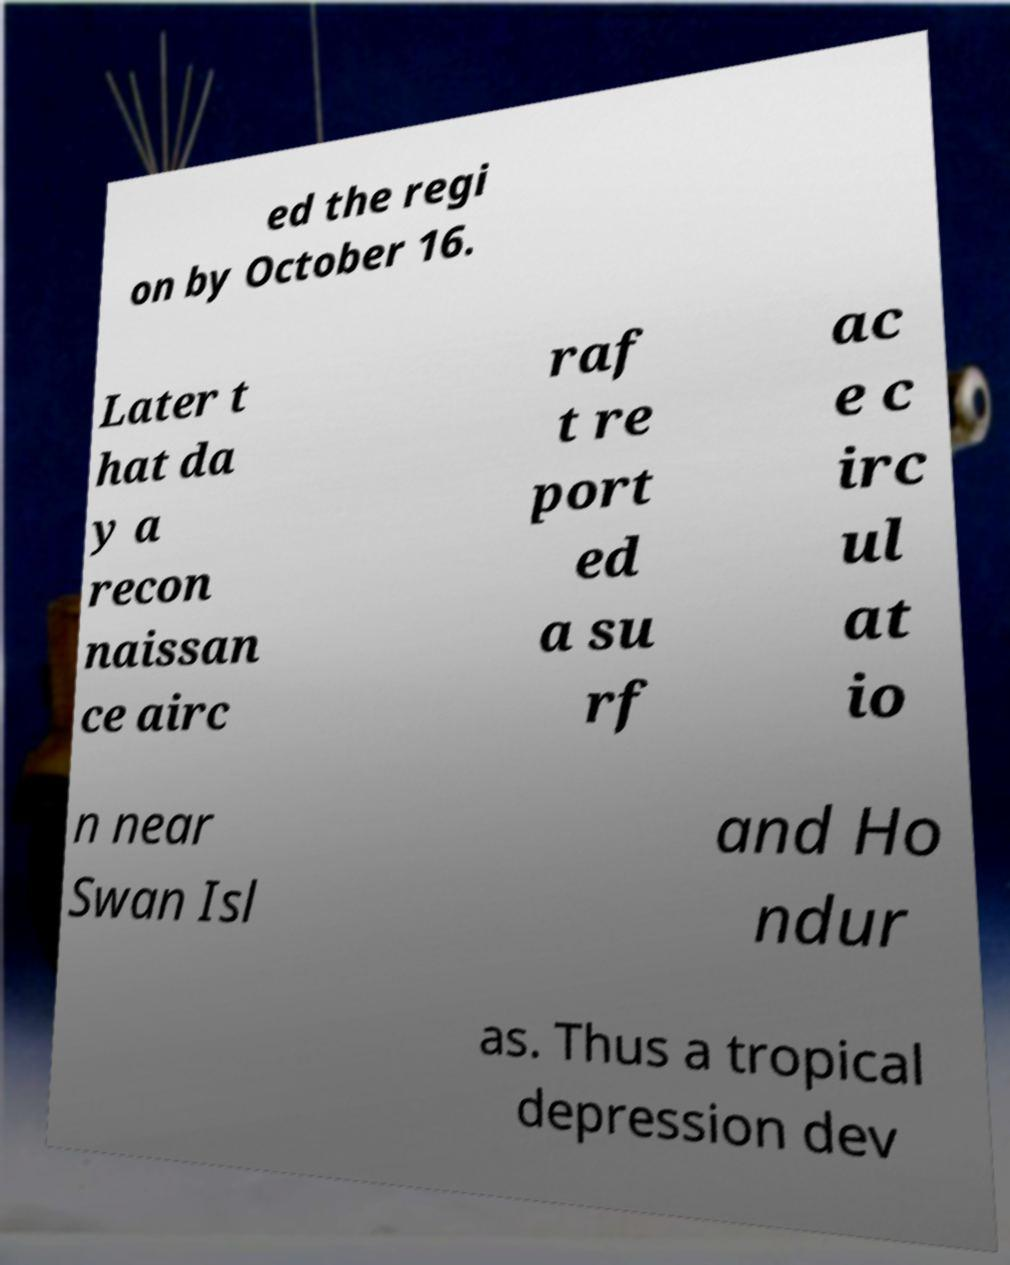For documentation purposes, I need the text within this image transcribed. Could you provide that? ed the regi on by October 16. Later t hat da y a recon naissan ce airc raf t re port ed a su rf ac e c irc ul at io n near Swan Isl and Ho ndur as. Thus a tropical depression dev 